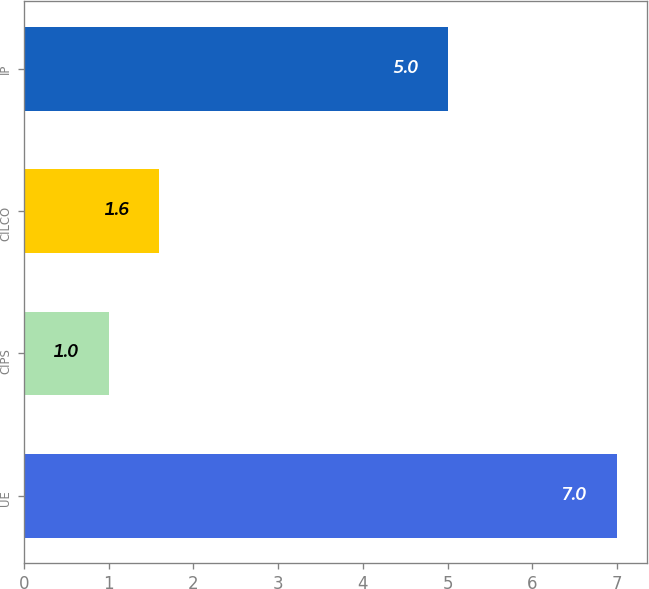Convert chart. <chart><loc_0><loc_0><loc_500><loc_500><bar_chart><fcel>UE<fcel>CIPS<fcel>CILCO<fcel>IP<nl><fcel>7<fcel>1<fcel>1.6<fcel>5<nl></chart> 